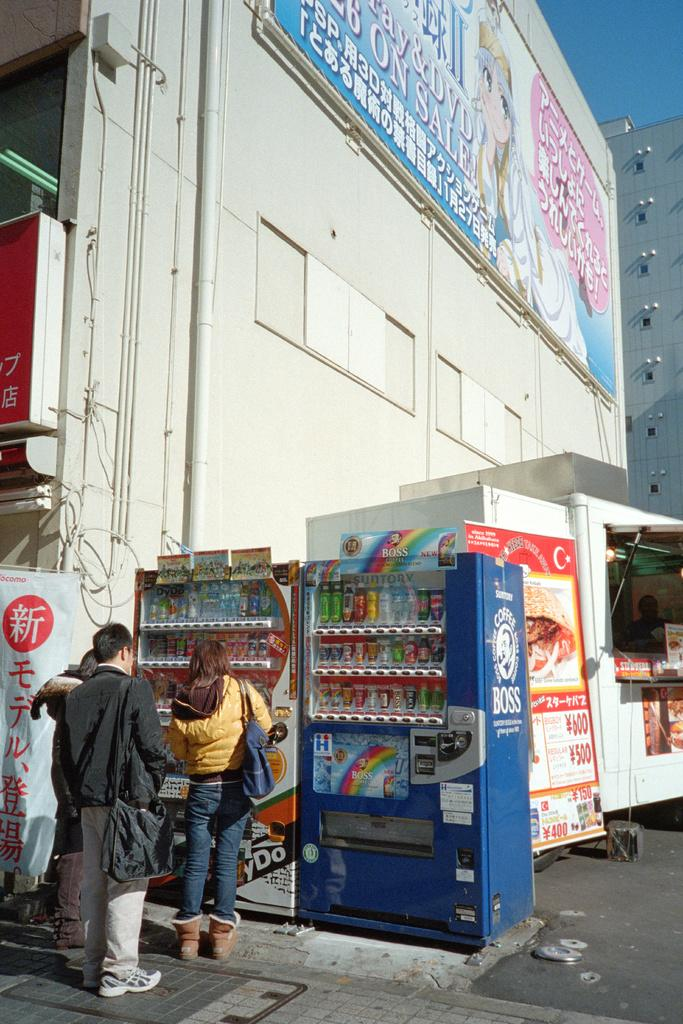Who or what can be seen in the image? There are people in the image. What type of commercial establishments are present in the image? Vending machines and a stall are present in the image. What type of signage is visible in the image? Banners are visible in the image. What type of infrastructure is present in the image? There is a road in the image. What can be seen in the background of the image? Buildings, boards, and the sky are visible in the background of the image. Can you see any fangs on the people in the image? There are no fangs visible on the people in the image. What type of form or system is being used to distribute the items in the stall? The image does not provide information about the distribution system or form used in the stall. 